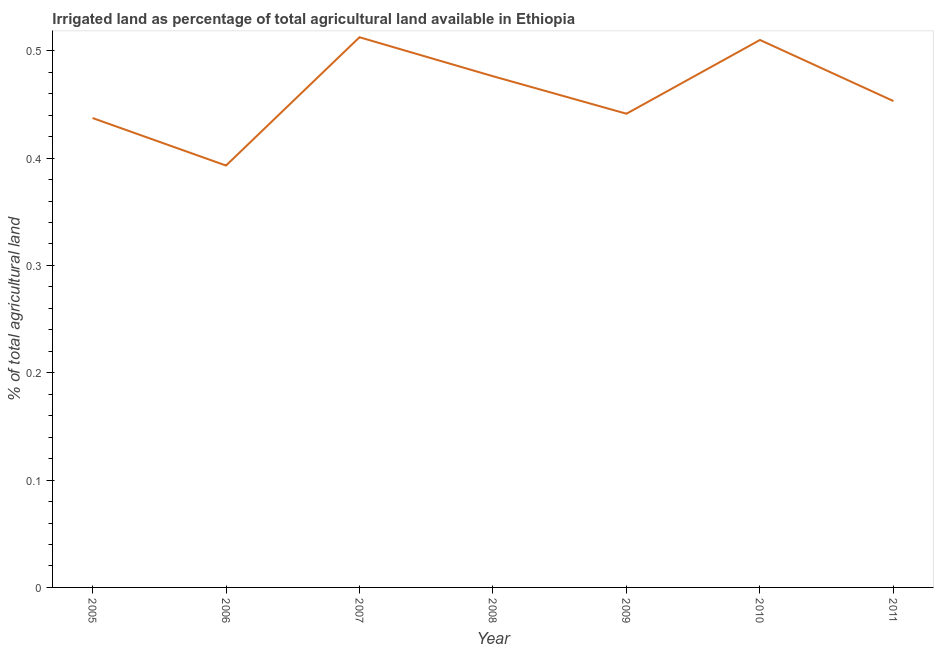What is the percentage of agricultural irrigated land in 2007?
Keep it short and to the point. 0.51. Across all years, what is the maximum percentage of agricultural irrigated land?
Offer a terse response. 0.51. Across all years, what is the minimum percentage of agricultural irrigated land?
Offer a terse response. 0.39. What is the sum of the percentage of agricultural irrigated land?
Your response must be concise. 3.22. What is the difference between the percentage of agricultural irrigated land in 2008 and 2011?
Offer a terse response. 0.02. What is the average percentage of agricultural irrigated land per year?
Keep it short and to the point. 0.46. What is the median percentage of agricultural irrigated land?
Your answer should be compact. 0.45. In how many years, is the percentage of agricultural irrigated land greater than 0.04 %?
Your response must be concise. 7. What is the ratio of the percentage of agricultural irrigated land in 2006 to that in 2007?
Keep it short and to the point. 0.77. What is the difference between the highest and the second highest percentage of agricultural irrigated land?
Provide a succinct answer. 0. Is the sum of the percentage of agricultural irrigated land in 2005 and 2011 greater than the maximum percentage of agricultural irrigated land across all years?
Offer a very short reply. Yes. What is the difference between the highest and the lowest percentage of agricultural irrigated land?
Provide a succinct answer. 0.12. In how many years, is the percentage of agricultural irrigated land greater than the average percentage of agricultural irrigated land taken over all years?
Keep it short and to the point. 3. How many years are there in the graph?
Your response must be concise. 7. What is the title of the graph?
Provide a succinct answer. Irrigated land as percentage of total agricultural land available in Ethiopia. What is the label or title of the Y-axis?
Make the answer very short. % of total agricultural land. What is the % of total agricultural land in 2005?
Provide a short and direct response. 0.44. What is the % of total agricultural land in 2006?
Give a very brief answer. 0.39. What is the % of total agricultural land of 2007?
Give a very brief answer. 0.51. What is the % of total agricultural land in 2008?
Provide a succinct answer. 0.48. What is the % of total agricultural land in 2009?
Offer a very short reply. 0.44. What is the % of total agricultural land of 2010?
Provide a succinct answer. 0.51. What is the % of total agricultural land of 2011?
Your response must be concise. 0.45. What is the difference between the % of total agricultural land in 2005 and 2006?
Your answer should be compact. 0.04. What is the difference between the % of total agricultural land in 2005 and 2007?
Keep it short and to the point. -0.08. What is the difference between the % of total agricultural land in 2005 and 2008?
Ensure brevity in your answer.  -0.04. What is the difference between the % of total agricultural land in 2005 and 2009?
Your answer should be compact. -0. What is the difference between the % of total agricultural land in 2005 and 2010?
Ensure brevity in your answer.  -0.07. What is the difference between the % of total agricultural land in 2005 and 2011?
Offer a terse response. -0.02. What is the difference between the % of total agricultural land in 2006 and 2007?
Provide a short and direct response. -0.12. What is the difference between the % of total agricultural land in 2006 and 2008?
Offer a terse response. -0.08. What is the difference between the % of total agricultural land in 2006 and 2009?
Your response must be concise. -0.05. What is the difference between the % of total agricultural land in 2006 and 2010?
Give a very brief answer. -0.12. What is the difference between the % of total agricultural land in 2006 and 2011?
Provide a succinct answer. -0.06. What is the difference between the % of total agricultural land in 2007 and 2008?
Offer a very short reply. 0.04. What is the difference between the % of total agricultural land in 2007 and 2009?
Your answer should be very brief. 0.07. What is the difference between the % of total agricultural land in 2007 and 2010?
Your answer should be compact. 0. What is the difference between the % of total agricultural land in 2007 and 2011?
Ensure brevity in your answer.  0.06. What is the difference between the % of total agricultural land in 2008 and 2009?
Provide a short and direct response. 0.03. What is the difference between the % of total agricultural land in 2008 and 2010?
Offer a terse response. -0.03. What is the difference between the % of total agricultural land in 2008 and 2011?
Your response must be concise. 0.02. What is the difference between the % of total agricultural land in 2009 and 2010?
Your response must be concise. -0.07. What is the difference between the % of total agricultural land in 2009 and 2011?
Your answer should be very brief. -0.01. What is the difference between the % of total agricultural land in 2010 and 2011?
Your response must be concise. 0.06. What is the ratio of the % of total agricultural land in 2005 to that in 2006?
Offer a terse response. 1.11. What is the ratio of the % of total agricultural land in 2005 to that in 2007?
Provide a succinct answer. 0.85. What is the ratio of the % of total agricultural land in 2005 to that in 2008?
Ensure brevity in your answer.  0.92. What is the ratio of the % of total agricultural land in 2005 to that in 2009?
Offer a very short reply. 0.99. What is the ratio of the % of total agricultural land in 2005 to that in 2010?
Give a very brief answer. 0.86. What is the ratio of the % of total agricultural land in 2005 to that in 2011?
Make the answer very short. 0.96. What is the ratio of the % of total agricultural land in 2006 to that in 2007?
Offer a terse response. 0.77. What is the ratio of the % of total agricultural land in 2006 to that in 2008?
Your answer should be very brief. 0.82. What is the ratio of the % of total agricultural land in 2006 to that in 2009?
Provide a short and direct response. 0.89. What is the ratio of the % of total agricultural land in 2006 to that in 2010?
Your answer should be compact. 0.77. What is the ratio of the % of total agricultural land in 2006 to that in 2011?
Give a very brief answer. 0.87. What is the ratio of the % of total agricultural land in 2007 to that in 2008?
Make the answer very short. 1.08. What is the ratio of the % of total agricultural land in 2007 to that in 2009?
Keep it short and to the point. 1.16. What is the ratio of the % of total agricultural land in 2007 to that in 2011?
Give a very brief answer. 1.13. What is the ratio of the % of total agricultural land in 2008 to that in 2009?
Ensure brevity in your answer.  1.08. What is the ratio of the % of total agricultural land in 2008 to that in 2010?
Your answer should be compact. 0.93. What is the ratio of the % of total agricultural land in 2008 to that in 2011?
Your response must be concise. 1.05. What is the ratio of the % of total agricultural land in 2009 to that in 2010?
Provide a succinct answer. 0.86. What is the ratio of the % of total agricultural land in 2009 to that in 2011?
Make the answer very short. 0.97. What is the ratio of the % of total agricultural land in 2010 to that in 2011?
Provide a short and direct response. 1.13. 